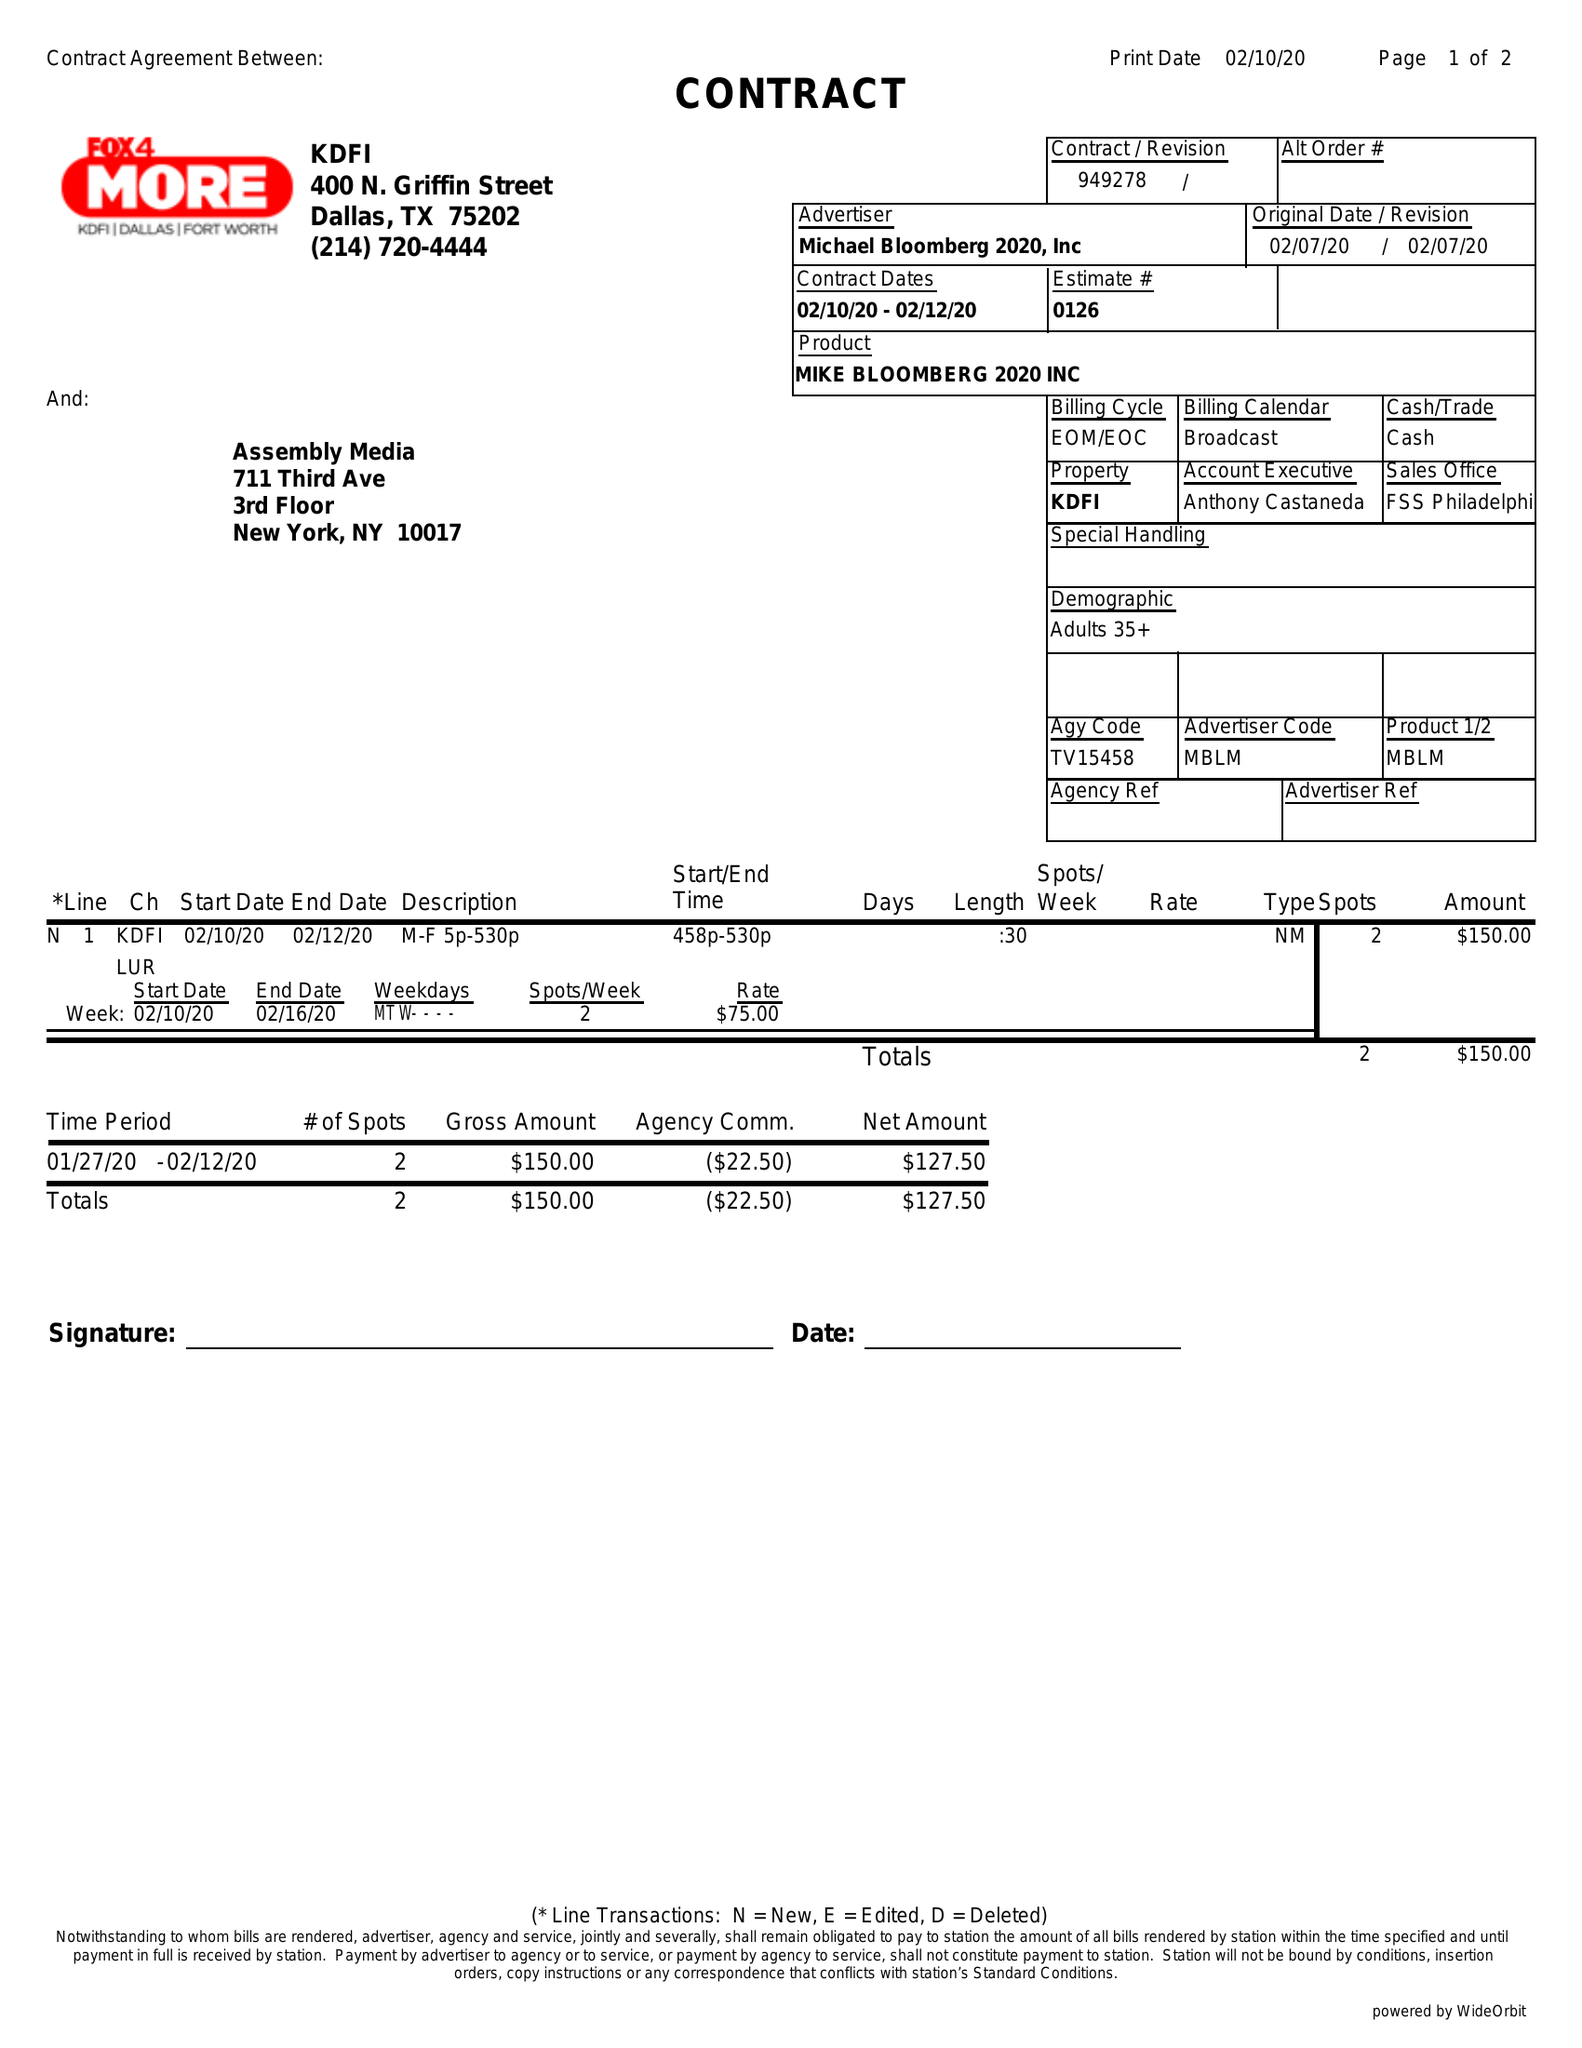What is the value for the flight_to?
Answer the question using a single word or phrase. 02/12/20 